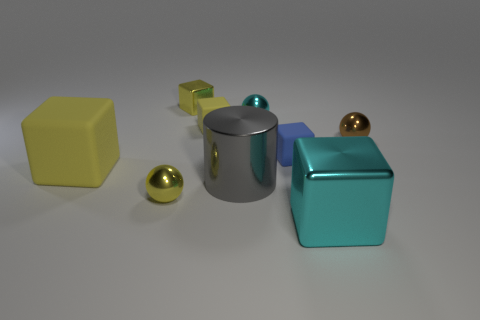What size is the yellow rubber block on the left side of the yellow metal thing that is behind the large metallic cylinder?
Make the answer very short. Large. The small matte object in front of the small matte block that is left of the cyan object behind the small brown metallic thing is what shape?
Your answer should be compact. Cube. The cyan sphere that is made of the same material as the big gray cylinder is what size?
Your answer should be very brief. Small. Are there more small shiny things than cylinders?
Give a very brief answer. Yes. There is a yellow thing that is the same size as the metal cylinder; what material is it?
Provide a succinct answer. Rubber. Do the block in front of the gray object and the small brown shiny object have the same size?
Your response must be concise. No. How many cylinders are either tiny cyan things or shiny things?
Offer a very short reply. 1. What material is the object to the right of the big cyan object?
Keep it short and to the point. Metal. Is the number of small red metallic cylinders less than the number of small blue rubber cubes?
Give a very brief answer. Yes. How big is the metallic ball that is both on the left side of the tiny blue thing and behind the small blue rubber cube?
Your answer should be very brief. Small. 